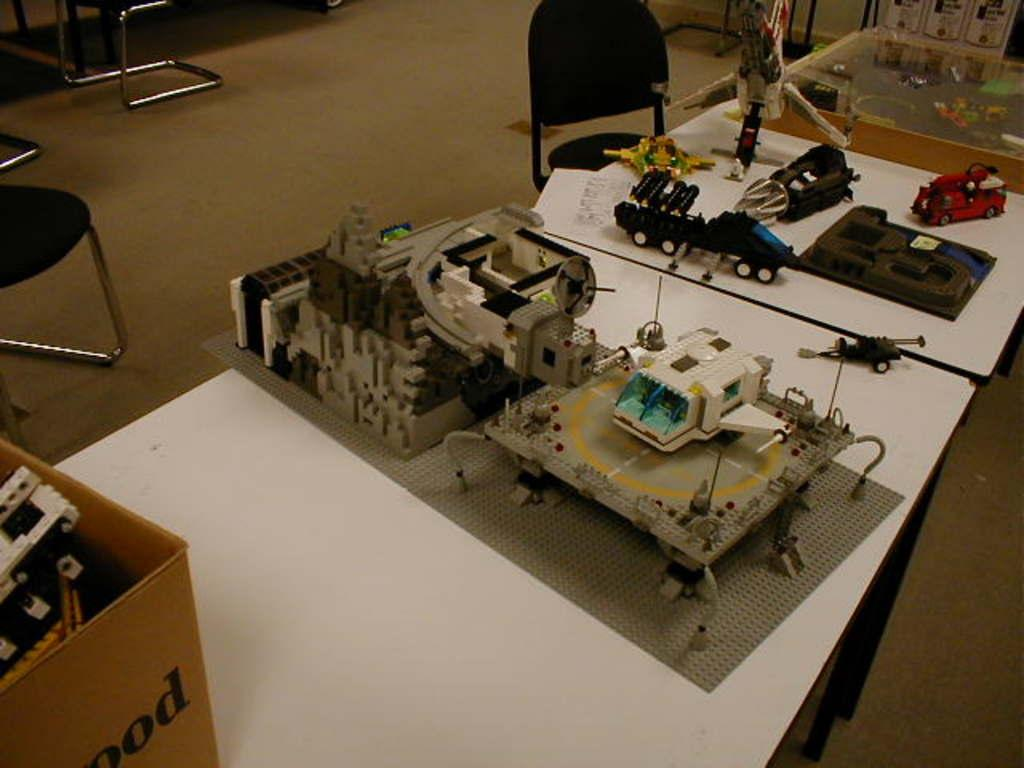What type of furniture is present in the image? There are tables in the image. What is placed on the tables? There is a box and multiple pieces of equipment on the tables. What can be seen in the background of the image? There are chairs in the background of the image. How many clover leaves are visible on the tables in the image? There are no clover leaves present in the image. What type of note is attached to the box on the tables? There is no note attached to the box on the tables in the image. 